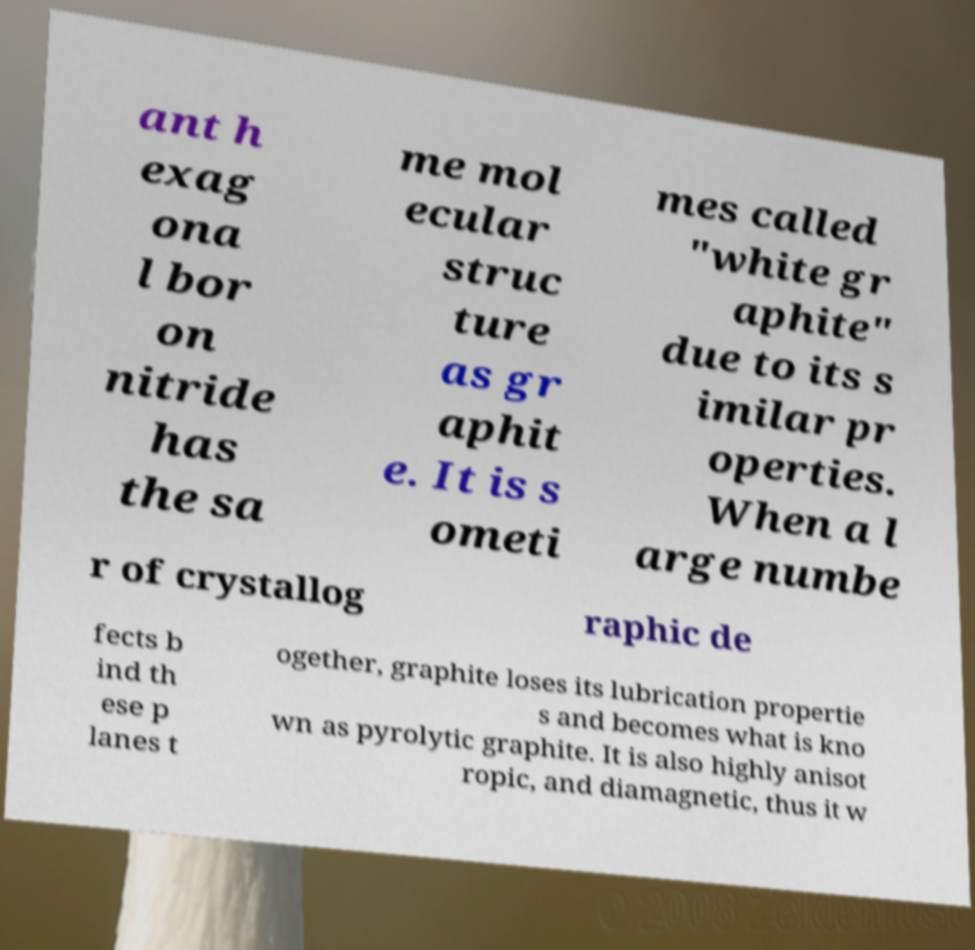What messages or text are displayed in this image? I need them in a readable, typed format. ant h exag ona l bor on nitride has the sa me mol ecular struc ture as gr aphit e. It is s ometi mes called "white gr aphite" due to its s imilar pr operties. When a l arge numbe r of crystallog raphic de fects b ind th ese p lanes t ogether, graphite loses its lubrication propertie s and becomes what is kno wn as pyrolytic graphite. It is also highly anisot ropic, and diamagnetic, thus it w 